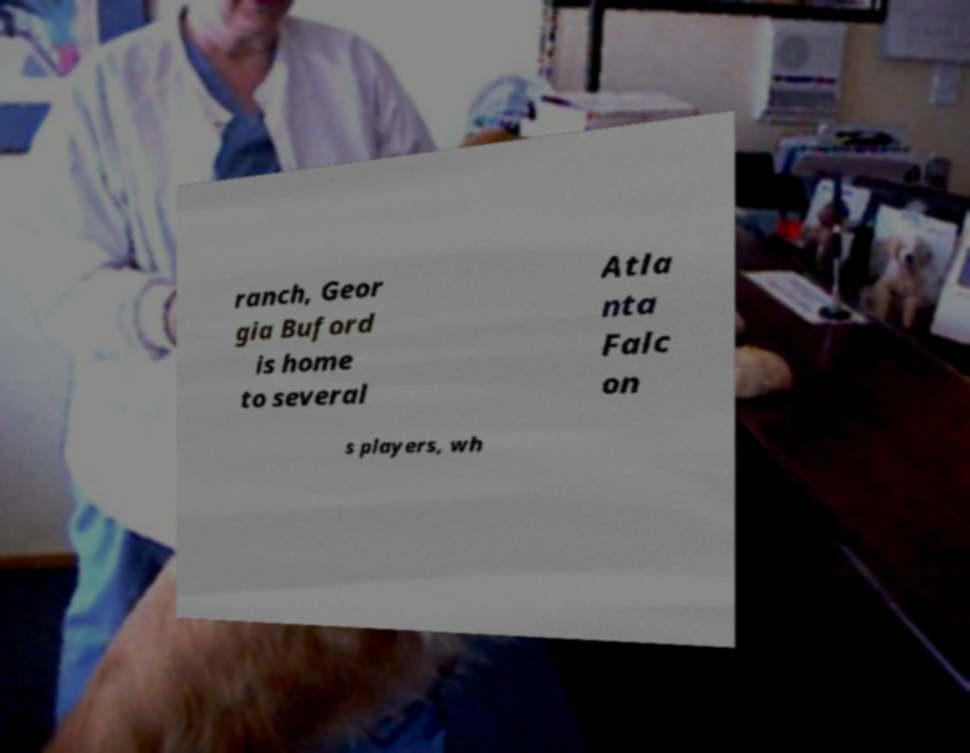What messages or text are displayed in this image? I need them in a readable, typed format. ranch, Geor gia Buford is home to several Atla nta Falc on s players, wh 